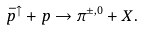<formula> <loc_0><loc_0><loc_500><loc_500>\bar { p } ^ { \uparrow } + p \to \pi ^ { \pm , 0 } + X .</formula> 